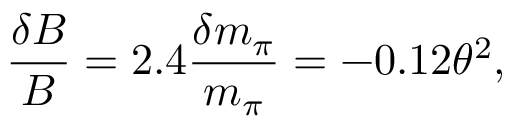<formula> <loc_0><loc_0><loc_500><loc_500>\frac { \delta B } { B } = 2 . 4 \frac { \delta m _ { \pi } } { m _ { \pi } } = - 0 . 1 2 \theta ^ { 2 } ,</formula> 